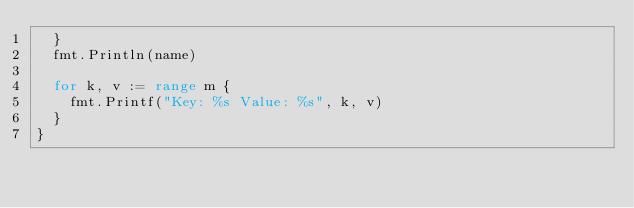Convert code to text. <code><loc_0><loc_0><loc_500><loc_500><_Go_>	}
	fmt.Println(name)

	for k, v := range m {
		fmt.Printf("Key: %s Value: %s", k, v)
	}
}
</code> 